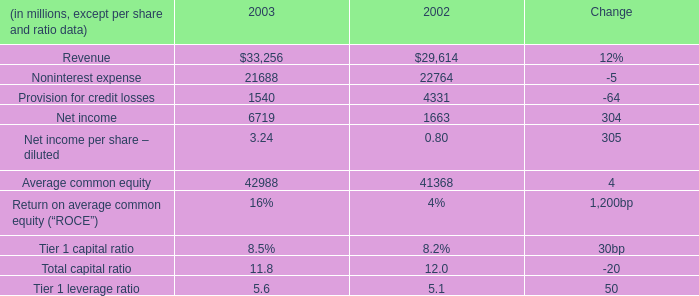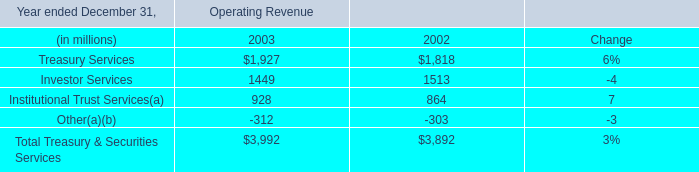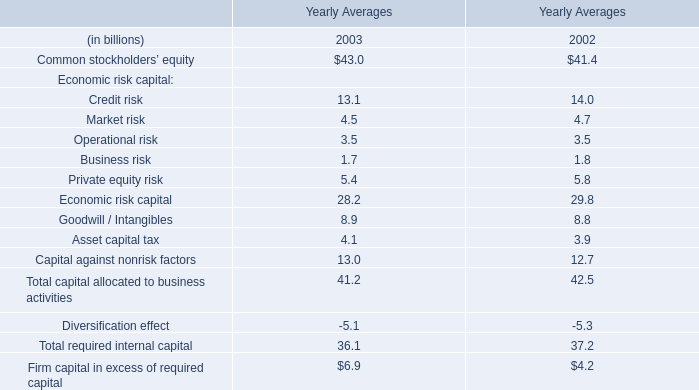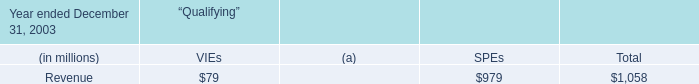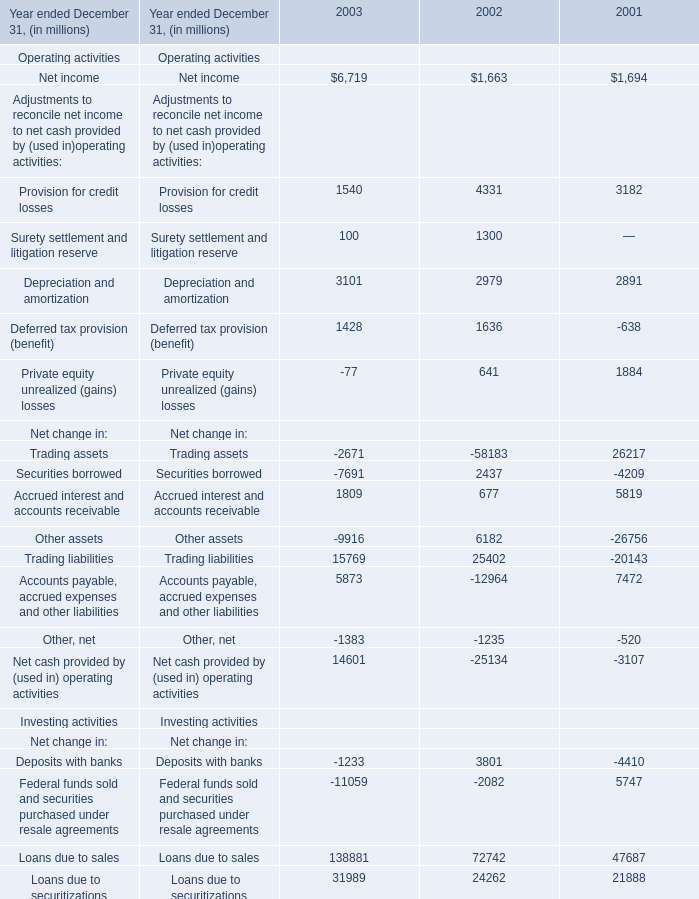What is the total amount of Other loans, net of 2002, and Provision for credit losses of 2003 ? 
Computations: (98695.0 + 1540.0)
Answer: 100235.0. 